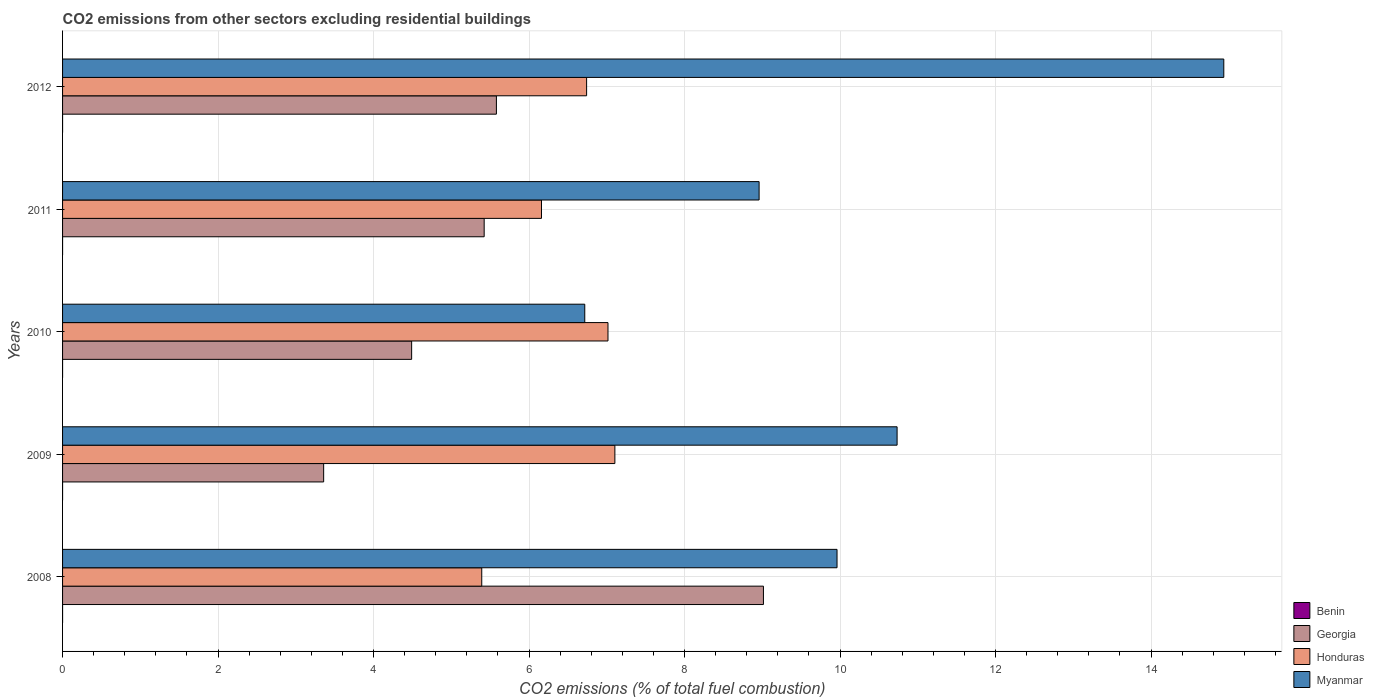Are the number of bars on each tick of the Y-axis equal?
Give a very brief answer. No. How many bars are there on the 1st tick from the top?
Offer a terse response. 4. What is the total CO2 emitted in Honduras in 2008?
Provide a short and direct response. 5.39. Across all years, what is the maximum total CO2 emitted in Georgia?
Your answer should be compact. 9.01. Across all years, what is the minimum total CO2 emitted in Honduras?
Ensure brevity in your answer.  5.39. In which year was the total CO2 emitted in Myanmar maximum?
Your response must be concise. 2012. What is the total total CO2 emitted in Benin in the graph?
Offer a very short reply. 7.807697859994709e-16. What is the difference between the total CO2 emitted in Honduras in 2009 and that in 2012?
Offer a terse response. 0.36. What is the difference between the total CO2 emitted in Honduras in 2010 and the total CO2 emitted in Benin in 2008?
Keep it short and to the point. 7.02. What is the average total CO2 emitted in Honduras per year?
Provide a succinct answer. 6.48. In the year 2012, what is the difference between the total CO2 emitted in Myanmar and total CO2 emitted in Honduras?
Make the answer very short. 8.2. In how many years, is the total CO2 emitted in Benin greater than 6.4 ?
Keep it short and to the point. 0. What is the ratio of the total CO2 emitted in Georgia in 2010 to that in 2012?
Ensure brevity in your answer.  0.8. Is the total CO2 emitted in Myanmar in 2008 less than that in 2009?
Make the answer very short. Yes. Is the difference between the total CO2 emitted in Myanmar in 2008 and 2009 greater than the difference between the total CO2 emitted in Honduras in 2008 and 2009?
Provide a short and direct response. Yes. What is the difference between the highest and the second highest total CO2 emitted in Myanmar?
Keep it short and to the point. 4.2. What is the difference between the highest and the lowest total CO2 emitted in Georgia?
Offer a very short reply. 5.66. Is it the case that in every year, the sum of the total CO2 emitted in Georgia and total CO2 emitted in Benin is greater than the sum of total CO2 emitted in Honduras and total CO2 emitted in Myanmar?
Your answer should be very brief. No. Is it the case that in every year, the sum of the total CO2 emitted in Honduras and total CO2 emitted in Benin is greater than the total CO2 emitted in Myanmar?
Make the answer very short. No. Are all the bars in the graph horizontal?
Your answer should be very brief. Yes. What is the difference between two consecutive major ticks on the X-axis?
Provide a short and direct response. 2. Are the values on the major ticks of X-axis written in scientific E-notation?
Give a very brief answer. No. Does the graph contain any zero values?
Your answer should be very brief. Yes. How are the legend labels stacked?
Give a very brief answer. Vertical. What is the title of the graph?
Offer a very short reply. CO2 emissions from other sectors excluding residential buildings. What is the label or title of the X-axis?
Provide a short and direct response. CO2 emissions (% of total fuel combustion). What is the label or title of the Y-axis?
Provide a short and direct response. Years. What is the CO2 emissions (% of total fuel combustion) in Benin in 2008?
Make the answer very short. 2.282530889443169e-16. What is the CO2 emissions (% of total fuel combustion) of Georgia in 2008?
Offer a terse response. 9.01. What is the CO2 emissions (% of total fuel combustion) of Honduras in 2008?
Your answer should be compact. 5.39. What is the CO2 emissions (% of total fuel combustion) of Myanmar in 2008?
Your answer should be compact. 9.96. What is the CO2 emissions (% of total fuel combustion) in Georgia in 2009?
Keep it short and to the point. 3.36. What is the CO2 emissions (% of total fuel combustion) in Honduras in 2009?
Ensure brevity in your answer.  7.1. What is the CO2 emissions (% of total fuel combustion) in Myanmar in 2009?
Offer a terse response. 10.73. What is the CO2 emissions (% of total fuel combustion) of Benin in 2010?
Make the answer very short. 1.92747052886312e-16. What is the CO2 emissions (% of total fuel combustion) in Georgia in 2010?
Provide a succinct answer. 4.49. What is the CO2 emissions (% of total fuel combustion) of Honduras in 2010?
Offer a very short reply. 7.02. What is the CO2 emissions (% of total fuel combustion) of Myanmar in 2010?
Ensure brevity in your answer.  6.72. What is the CO2 emissions (% of total fuel combustion) of Benin in 2011?
Keep it short and to the point. 1.84545050635831e-16. What is the CO2 emissions (% of total fuel combustion) of Georgia in 2011?
Keep it short and to the point. 5.42. What is the CO2 emissions (% of total fuel combustion) of Honduras in 2011?
Your answer should be compact. 6.16. What is the CO2 emissions (% of total fuel combustion) in Myanmar in 2011?
Ensure brevity in your answer.  8.96. What is the CO2 emissions (% of total fuel combustion) of Benin in 2012?
Give a very brief answer. 1.75224593533011e-16. What is the CO2 emissions (% of total fuel combustion) in Georgia in 2012?
Your response must be concise. 5.58. What is the CO2 emissions (% of total fuel combustion) of Honduras in 2012?
Keep it short and to the point. 6.74. What is the CO2 emissions (% of total fuel combustion) of Myanmar in 2012?
Offer a terse response. 14.94. Across all years, what is the maximum CO2 emissions (% of total fuel combustion) in Benin?
Make the answer very short. 2.282530889443169e-16. Across all years, what is the maximum CO2 emissions (% of total fuel combustion) of Georgia?
Provide a succinct answer. 9.01. Across all years, what is the maximum CO2 emissions (% of total fuel combustion) in Honduras?
Keep it short and to the point. 7.1. Across all years, what is the maximum CO2 emissions (% of total fuel combustion) in Myanmar?
Keep it short and to the point. 14.94. Across all years, what is the minimum CO2 emissions (% of total fuel combustion) of Georgia?
Make the answer very short. 3.36. Across all years, what is the minimum CO2 emissions (% of total fuel combustion) of Honduras?
Your response must be concise. 5.39. Across all years, what is the minimum CO2 emissions (% of total fuel combustion) in Myanmar?
Offer a very short reply. 6.72. What is the total CO2 emissions (% of total fuel combustion) of Georgia in the graph?
Make the answer very short. 27.87. What is the total CO2 emissions (% of total fuel combustion) in Honduras in the graph?
Your answer should be compact. 32.41. What is the total CO2 emissions (% of total fuel combustion) in Myanmar in the graph?
Offer a terse response. 51.31. What is the difference between the CO2 emissions (% of total fuel combustion) in Georgia in 2008 and that in 2009?
Your answer should be compact. 5.66. What is the difference between the CO2 emissions (% of total fuel combustion) in Honduras in 2008 and that in 2009?
Provide a short and direct response. -1.71. What is the difference between the CO2 emissions (% of total fuel combustion) of Myanmar in 2008 and that in 2009?
Provide a succinct answer. -0.77. What is the difference between the CO2 emissions (% of total fuel combustion) of Benin in 2008 and that in 2010?
Ensure brevity in your answer.  0. What is the difference between the CO2 emissions (% of total fuel combustion) of Georgia in 2008 and that in 2010?
Your response must be concise. 4.52. What is the difference between the CO2 emissions (% of total fuel combustion) of Honduras in 2008 and that in 2010?
Your answer should be compact. -1.62. What is the difference between the CO2 emissions (% of total fuel combustion) of Myanmar in 2008 and that in 2010?
Make the answer very short. 3.24. What is the difference between the CO2 emissions (% of total fuel combustion) in Benin in 2008 and that in 2011?
Provide a succinct answer. 0. What is the difference between the CO2 emissions (% of total fuel combustion) of Georgia in 2008 and that in 2011?
Provide a short and direct response. 3.59. What is the difference between the CO2 emissions (% of total fuel combustion) of Honduras in 2008 and that in 2011?
Provide a short and direct response. -0.77. What is the difference between the CO2 emissions (% of total fuel combustion) of Myanmar in 2008 and that in 2011?
Offer a terse response. 1. What is the difference between the CO2 emissions (% of total fuel combustion) of Benin in 2008 and that in 2012?
Provide a short and direct response. 0. What is the difference between the CO2 emissions (% of total fuel combustion) of Georgia in 2008 and that in 2012?
Give a very brief answer. 3.43. What is the difference between the CO2 emissions (% of total fuel combustion) in Honduras in 2008 and that in 2012?
Provide a short and direct response. -1.35. What is the difference between the CO2 emissions (% of total fuel combustion) in Myanmar in 2008 and that in 2012?
Your response must be concise. -4.97. What is the difference between the CO2 emissions (% of total fuel combustion) in Georgia in 2009 and that in 2010?
Offer a very short reply. -1.13. What is the difference between the CO2 emissions (% of total fuel combustion) in Honduras in 2009 and that in 2010?
Your response must be concise. 0.09. What is the difference between the CO2 emissions (% of total fuel combustion) of Myanmar in 2009 and that in 2010?
Keep it short and to the point. 4.02. What is the difference between the CO2 emissions (% of total fuel combustion) of Georgia in 2009 and that in 2011?
Provide a short and direct response. -2.06. What is the difference between the CO2 emissions (% of total fuel combustion) of Honduras in 2009 and that in 2011?
Your answer should be compact. 0.94. What is the difference between the CO2 emissions (% of total fuel combustion) in Myanmar in 2009 and that in 2011?
Make the answer very short. 1.77. What is the difference between the CO2 emissions (% of total fuel combustion) in Georgia in 2009 and that in 2012?
Offer a terse response. -2.22. What is the difference between the CO2 emissions (% of total fuel combustion) of Honduras in 2009 and that in 2012?
Your answer should be compact. 0.36. What is the difference between the CO2 emissions (% of total fuel combustion) of Myanmar in 2009 and that in 2012?
Your response must be concise. -4.2. What is the difference between the CO2 emissions (% of total fuel combustion) of Benin in 2010 and that in 2011?
Your answer should be compact. 0. What is the difference between the CO2 emissions (% of total fuel combustion) in Georgia in 2010 and that in 2011?
Provide a succinct answer. -0.93. What is the difference between the CO2 emissions (% of total fuel combustion) in Honduras in 2010 and that in 2011?
Offer a terse response. 0.86. What is the difference between the CO2 emissions (% of total fuel combustion) of Myanmar in 2010 and that in 2011?
Make the answer very short. -2.24. What is the difference between the CO2 emissions (% of total fuel combustion) in Benin in 2010 and that in 2012?
Your answer should be compact. 0. What is the difference between the CO2 emissions (% of total fuel combustion) of Georgia in 2010 and that in 2012?
Ensure brevity in your answer.  -1.09. What is the difference between the CO2 emissions (% of total fuel combustion) of Honduras in 2010 and that in 2012?
Your answer should be compact. 0.27. What is the difference between the CO2 emissions (% of total fuel combustion) of Myanmar in 2010 and that in 2012?
Make the answer very short. -8.22. What is the difference between the CO2 emissions (% of total fuel combustion) of Benin in 2011 and that in 2012?
Your answer should be compact. 0. What is the difference between the CO2 emissions (% of total fuel combustion) in Georgia in 2011 and that in 2012?
Provide a short and direct response. -0.16. What is the difference between the CO2 emissions (% of total fuel combustion) in Honduras in 2011 and that in 2012?
Keep it short and to the point. -0.58. What is the difference between the CO2 emissions (% of total fuel combustion) of Myanmar in 2011 and that in 2012?
Your answer should be very brief. -5.98. What is the difference between the CO2 emissions (% of total fuel combustion) of Benin in 2008 and the CO2 emissions (% of total fuel combustion) of Georgia in 2009?
Ensure brevity in your answer.  -3.36. What is the difference between the CO2 emissions (% of total fuel combustion) of Benin in 2008 and the CO2 emissions (% of total fuel combustion) of Honduras in 2009?
Ensure brevity in your answer.  -7.1. What is the difference between the CO2 emissions (% of total fuel combustion) of Benin in 2008 and the CO2 emissions (% of total fuel combustion) of Myanmar in 2009?
Offer a very short reply. -10.73. What is the difference between the CO2 emissions (% of total fuel combustion) of Georgia in 2008 and the CO2 emissions (% of total fuel combustion) of Honduras in 2009?
Offer a very short reply. 1.91. What is the difference between the CO2 emissions (% of total fuel combustion) of Georgia in 2008 and the CO2 emissions (% of total fuel combustion) of Myanmar in 2009?
Make the answer very short. -1.72. What is the difference between the CO2 emissions (% of total fuel combustion) in Honduras in 2008 and the CO2 emissions (% of total fuel combustion) in Myanmar in 2009?
Your answer should be compact. -5.34. What is the difference between the CO2 emissions (% of total fuel combustion) of Benin in 2008 and the CO2 emissions (% of total fuel combustion) of Georgia in 2010?
Provide a short and direct response. -4.49. What is the difference between the CO2 emissions (% of total fuel combustion) of Benin in 2008 and the CO2 emissions (% of total fuel combustion) of Honduras in 2010?
Offer a terse response. -7.02. What is the difference between the CO2 emissions (% of total fuel combustion) of Benin in 2008 and the CO2 emissions (% of total fuel combustion) of Myanmar in 2010?
Your answer should be very brief. -6.72. What is the difference between the CO2 emissions (% of total fuel combustion) of Georgia in 2008 and the CO2 emissions (% of total fuel combustion) of Honduras in 2010?
Offer a terse response. 2. What is the difference between the CO2 emissions (% of total fuel combustion) of Georgia in 2008 and the CO2 emissions (% of total fuel combustion) of Myanmar in 2010?
Ensure brevity in your answer.  2.3. What is the difference between the CO2 emissions (% of total fuel combustion) in Honduras in 2008 and the CO2 emissions (% of total fuel combustion) in Myanmar in 2010?
Your answer should be very brief. -1.32. What is the difference between the CO2 emissions (% of total fuel combustion) in Benin in 2008 and the CO2 emissions (% of total fuel combustion) in Georgia in 2011?
Provide a succinct answer. -5.42. What is the difference between the CO2 emissions (% of total fuel combustion) of Benin in 2008 and the CO2 emissions (% of total fuel combustion) of Honduras in 2011?
Offer a very short reply. -6.16. What is the difference between the CO2 emissions (% of total fuel combustion) in Benin in 2008 and the CO2 emissions (% of total fuel combustion) in Myanmar in 2011?
Give a very brief answer. -8.96. What is the difference between the CO2 emissions (% of total fuel combustion) of Georgia in 2008 and the CO2 emissions (% of total fuel combustion) of Honduras in 2011?
Provide a short and direct response. 2.85. What is the difference between the CO2 emissions (% of total fuel combustion) of Georgia in 2008 and the CO2 emissions (% of total fuel combustion) of Myanmar in 2011?
Keep it short and to the point. 0.06. What is the difference between the CO2 emissions (% of total fuel combustion) in Honduras in 2008 and the CO2 emissions (% of total fuel combustion) in Myanmar in 2011?
Keep it short and to the point. -3.57. What is the difference between the CO2 emissions (% of total fuel combustion) of Benin in 2008 and the CO2 emissions (% of total fuel combustion) of Georgia in 2012?
Keep it short and to the point. -5.58. What is the difference between the CO2 emissions (% of total fuel combustion) of Benin in 2008 and the CO2 emissions (% of total fuel combustion) of Honduras in 2012?
Your answer should be compact. -6.74. What is the difference between the CO2 emissions (% of total fuel combustion) in Benin in 2008 and the CO2 emissions (% of total fuel combustion) in Myanmar in 2012?
Keep it short and to the point. -14.94. What is the difference between the CO2 emissions (% of total fuel combustion) of Georgia in 2008 and the CO2 emissions (% of total fuel combustion) of Honduras in 2012?
Offer a terse response. 2.27. What is the difference between the CO2 emissions (% of total fuel combustion) in Georgia in 2008 and the CO2 emissions (% of total fuel combustion) in Myanmar in 2012?
Your response must be concise. -5.92. What is the difference between the CO2 emissions (% of total fuel combustion) in Honduras in 2008 and the CO2 emissions (% of total fuel combustion) in Myanmar in 2012?
Provide a short and direct response. -9.54. What is the difference between the CO2 emissions (% of total fuel combustion) of Georgia in 2009 and the CO2 emissions (% of total fuel combustion) of Honduras in 2010?
Give a very brief answer. -3.66. What is the difference between the CO2 emissions (% of total fuel combustion) in Georgia in 2009 and the CO2 emissions (% of total fuel combustion) in Myanmar in 2010?
Ensure brevity in your answer.  -3.36. What is the difference between the CO2 emissions (% of total fuel combustion) in Honduras in 2009 and the CO2 emissions (% of total fuel combustion) in Myanmar in 2010?
Your response must be concise. 0.39. What is the difference between the CO2 emissions (% of total fuel combustion) of Georgia in 2009 and the CO2 emissions (% of total fuel combustion) of Honduras in 2011?
Keep it short and to the point. -2.8. What is the difference between the CO2 emissions (% of total fuel combustion) of Georgia in 2009 and the CO2 emissions (% of total fuel combustion) of Myanmar in 2011?
Make the answer very short. -5.6. What is the difference between the CO2 emissions (% of total fuel combustion) of Honduras in 2009 and the CO2 emissions (% of total fuel combustion) of Myanmar in 2011?
Keep it short and to the point. -1.85. What is the difference between the CO2 emissions (% of total fuel combustion) in Georgia in 2009 and the CO2 emissions (% of total fuel combustion) in Honduras in 2012?
Make the answer very short. -3.38. What is the difference between the CO2 emissions (% of total fuel combustion) of Georgia in 2009 and the CO2 emissions (% of total fuel combustion) of Myanmar in 2012?
Offer a terse response. -11.58. What is the difference between the CO2 emissions (% of total fuel combustion) of Honduras in 2009 and the CO2 emissions (% of total fuel combustion) of Myanmar in 2012?
Provide a short and direct response. -7.83. What is the difference between the CO2 emissions (% of total fuel combustion) of Benin in 2010 and the CO2 emissions (% of total fuel combustion) of Georgia in 2011?
Offer a very short reply. -5.42. What is the difference between the CO2 emissions (% of total fuel combustion) of Benin in 2010 and the CO2 emissions (% of total fuel combustion) of Honduras in 2011?
Offer a terse response. -6.16. What is the difference between the CO2 emissions (% of total fuel combustion) of Benin in 2010 and the CO2 emissions (% of total fuel combustion) of Myanmar in 2011?
Give a very brief answer. -8.96. What is the difference between the CO2 emissions (% of total fuel combustion) of Georgia in 2010 and the CO2 emissions (% of total fuel combustion) of Honduras in 2011?
Ensure brevity in your answer.  -1.67. What is the difference between the CO2 emissions (% of total fuel combustion) in Georgia in 2010 and the CO2 emissions (% of total fuel combustion) in Myanmar in 2011?
Provide a short and direct response. -4.47. What is the difference between the CO2 emissions (% of total fuel combustion) in Honduras in 2010 and the CO2 emissions (% of total fuel combustion) in Myanmar in 2011?
Make the answer very short. -1.94. What is the difference between the CO2 emissions (% of total fuel combustion) in Benin in 2010 and the CO2 emissions (% of total fuel combustion) in Georgia in 2012?
Make the answer very short. -5.58. What is the difference between the CO2 emissions (% of total fuel combustion) in Benin in 2010 and the CO2 emissions (% of total fuel combustion) in Honduras in 2012?
Your answer should be compact. -6.74. What is the difference between the CO2 emissions (% of total fuel combustion) in Benin in 2010 and the CO2 emissions (% of total fuel combustion) in Myanmar in 2012?
Make the answer very short. -14.94. What is the difference between the CO2 emissions (% of total fuel combustion) in Georgia in 2010 and the CO2 emissions (% of total fuel combustion) in Honduras in 2012?
Ensure brevity in your answer.  -2.25. What is the difference between the CO2 emissions (% of total fuel combustion) in Georgia in 2010 and the CO2 emissions (% of total fuel combustion) in Myanmar in 2012?
Ensure brevity in your answer.  -10.45. What is the difference between the CO2 emissions (% of total fuel combustion) in Honduras in 2010 and the CO2 emissions (% of total fuel combustion) in Myanmar in 2012?
Provide a succinct answer. -7.92. What is the difference between the CO2 emissions (% of total fuel combustion) in Benin in 2011 and the CO2 emissions (% of total fuel combustion) in Georgia in 2012?
Offer a very short reply. -5.58. What is the difference between the CO2 emissions (% of total fuel combustion) of Benin in 2011 and the CO2 emissions (% of total fuel combustion) of Honduras in 2012?
Provide a short and direct response. -6.74. What is the difference between the CO2 emissions (% of total fuel combustion) in Benin in 2011 and the CO2 emissions (% of total fuel combustion) in Myanmar in 2012?
Your answer should be very brief. -14.94. What is the difference between the CO2 emissions (% of total fuel combustion) of Georgia in 2011 and the CO2 emissions (% of total fuel combustion) of Honduras in 2012?
Offer a very short reply. -1.32. What is the difference between the CO2 emissions (% of total fuel combustion) in Georgia in 2011 and the CO2 emissions (% of total fuel combustion) in Myanmar in 2012?
Offer a terse response. -9.51. What is the difference between the CO2 emissions (% of total fuel combustion) in Honduras in 2011 and the CO2 emissions (% of total fuel combustion) in Myanmar in 2012?
Ensure brevity in your answer.  -8.78. What is the average CO2 emissions (% of total fuel combustion) of Georgia per year?
Ensure brevity in your answer.  5.57. What is the average CO2 emissions (% of total fuel combustion) of Honduras per year?
Offer a very short reply. 6.48. What is the average CO2 emissions (% of total fuel combustion) of Myanmar per year?
Your response must be concise. 10.26. In the year 2008, what is the difference between the CO2 emissions (% of total fuel combustion) in Benin and CO2 emissions (% of total fuel combustion) in Georgia?
Give a very brief answer. -9.01. In the year 2008, what is the difference between the CO2 emissions (% of total fuel combustion) of Benin and CO2 emissions (% of total fuel combustion) of Honduras?
Your response must be concise. -5.39. In the year 2008, what is the difference between the CO2 emissions (% of total fuel combustion) in Benin and CO2 emissions (% of total fuel combustion) in Myanmar?
Your response must be concise. -9.96. In the year 2008, what is the difference between the CO2 emissions (% of total fuel combustion) in Georgia and CO2 emissions (% of total fuel combustion) in Honduras?
Your answer should be very brief. 3.62. In the year 2008, what is the difference between the CO2 emissions (% of total fuel combustion) in Georgia and CO2 emissions (% of total fuel combustion) in Myanmar?
Your response must be concise. -0.95. In the year 2008, what is the difference between the CO2 emissions (% of total fuel combustion) of Honduras and CO2 emissions (% of total fuel combustion) of Myanmar?
Ensure brevity in your answer.  -4.57. In the year 2009, what is the difference between the CO2 emissions (% of total fuel combustion) in Georgia and CO2 emissions (% of total fuel combustion) in Honduras?
Give a very brief answer. -3.75. In the year 2009, what is the difference between the CO2 emissions (% of total fuel combustion) of Georgia and CO2 emissions (% of total fuel combustion) of Myanmar?
Ensure brevity in your answer.  -7.38. In the year 2009, what is the difference between the CO2 emissions (% of total fuel combustion) of Honduras and CO2 emissions (% of total fuel combustion) of Myanmar?
Offer a very short reply. -3.63. In the year 2010, what is the difference between the CO2 emissions (% of total fuel combustion) of Benin and CO2 emissions (% of total fuel combustion) of Georgia?
Ensure brevity in your answer.  -4.49. In the year 2010, what is the difference between the CO2 emissions (% of total fuel combustion) of Benin and CO2 emissions (% of total fuel combustion) of Honduras?
Provide a succinct answer. -7.02. In the year 2010, what is the difference between the CO2 emissions (% of total fuel combustion) in Benin and CO2 emissions (% of total fuel combustion) in Myanmar?
Make the answer very short. -6.72. In the year 2010, what is the difference between the CO2 emissions (% of total fuel combustion) of Georgia and CO2 emissions (% of total fuel combustion) of Honduras?
Offer a very short reply. -2.53. In the year 2010, what is the difference between the CO2 emissions (% of total fuel combustion) in Georgia and CO2 emissions (% of total fuel combustion) in Myanmar?
Offer a terse response. -2.23. In the year 2010, what is the difference between the CO2 emissions (% of total fuel combustion) in Honduras and CO2 emissions (% of total fuel combustion) in Myanmar?
Your response must be concise. 0.3. In the year 2011, what is the difference between the CO2 emissions (% of total fuel combustion) of Benin and CO2 emissions (% of total fuel combustion) of Georgia?
Give a very brief answer. -5.42. In the year 2011, what is the difference between the CO2 emissions (% of total fuel combustion) in Benin and CO2 emissions (% of total fuel combustion) in Honduras?
Keep it short and to the point. -6.16. In the year 2011, what is the difference between the CO2 emissions (% of total fuel combustion) of Benin and CO2 emissions (% of total fuel combustion) of Myanmar?
Offer a terse response. -8.96. In the year 2011, what is the difference between the CO2 emissions (% of total fuel combustion) in Georgia and CO2 emissions (% of total fuel combustion) in Honduras?
Offer a terse response. -0.74. In the year 2011, what is the difference between the CO2 emissions (% of total fuel combustion) in Georgia and CO2 emissions (% of total fuel combustion) in Myanmar?
Your response must be concise. -3.54. In the year 2011, what is the difference between the CO2 emissions (% of total fuel combustion) in Honduras and CO2 emissions (% of total fuel combustion) in Myanmar?
Offer a terse response. -2.8. In the year 2012, what is the difference between the CO2 emissions (% of total fuel combustion) of Benin and CO2 emissions (% of total fuel combustion) of Georgia?
Give a very brief answer. -5.58. In the year 2012, what is the difference between the CO2 emissions (% of total fuel combustion) in Benin and CO2 emissions (% of total fuel combustion) in Honduras?
Your response must be concise. -6.74. In the year 2012, what is the difference between the CO2 emissions (% of total fuel combustion) in Benin and CO2 emissions (% of total fuel combustion) in Myanmar?
Provide a short and direct response. -14.94. In the year 2012, what is the difference between the CO2 emissions (% of total fuel combustion) of Georgia and CO2 emissions (% of total fuel combustion) of Honduras?
Give a very brief answer. -1.16. In the year 2012, what is the difference between the CO2 emissions (% of total fuel combustion) in Georgia and CO2 emissions (% of total fuel combustion) in Myanmar?
Your answer should be compact. -9.36. In the year 2012, what is the difference between the CO2 emissions (% of total fuel combustion) of Honduras and CO2 emissions (% of total fuel combustion) of Myanmar?
Make the answer very short. -8.2. What is the ratio of the CO2 emissions (% of total fuel combustion) in Georgia in 2008 to that in 2009?
Your response must be concise. 2.68. What is the ratio of the CO2 emissions (% of total fuel combustion) of Honduras in 2008 to that in 2009?
Provide a succinct answer. 0.76. What is the ratio of the CO2 emissions (% of total fuel combustion) of Myanmar in 2008 to that in 2009?
Keep it short and to the point. 0.93. What is the ratio of the CO2 emissions (% of total fuel combustion) in Benin in 2008 to that in 2010?
Your answer should be compact. 1.18. What is the ratio of the CO2 emissions (% of total fuel combustion) in Georgia in 2008 to that in 2010?
Your answer should be compact. 2.01. What is the ratio of the CO2 emissions (% of total fuel combustion) of Honduras in 2008 to that in 2010?
Provide a short and direct response. 0.77. What is the ratio of the CO2 emissions (% of total fuel combustion) in Myanmar in 2008 to that in 2010?
Give a very brief answer. 1.48. What is the ratio of the CO2 emissions (% of total fuel combustion) of Benin in 2008 to that in 2011?
Ensure brevity in your answer.  1.24. What is the ratio of the CO2 emissions (% of total fuel combustion) of Georgia in 2008 to that in 2011?
Your answer should be very brief. 1.66. What is the ratio of the CO2 emissions (% of total fuel combustion) in Honduras in 2008 to that in 2011?
Your answer should be very brief. 0.88. What is the ratio of the CO2 emissions (% of total fuel combustion) in Myanmar in 2008 to that in 2011?
Your response must be concise. 1.11. What is the ratio of the CO2 emissions (% of total fuel combustion) of Benin in 2008 to that in 2012?
Your answer should be very brief. 1.3. What is the ratio of the CO2 emissions (% of total fuel combustion) of Georgia in 2008 to that in 2012?
Offer a terse response. 1.62. What is the ratio of the CO2 emissions (% of total fuel combustion) in Honduras in 2008 to that in 2012?
Give a very brief answer. 0.8. What is the ratio of the CO2 emissions (% of total fuel combustion) of Myanmar in 2008 to that in 2012?
Provide a short and direct response. 0.67. What is the ratio of the CO2 emissions (% of total fuel combustion) in Georgia in 2009 to that in 2010?
Your answer should be compact. 0.75. What is the ratio of the CO2 emissions (% of total fuel combustion) of Honduras in 2009 to that in 2010?
Offer a terse response. 1.01. What is the ratio of the CO2 emissions (% of total fuel combustion) of Myanmar in 2009 to that in 2010?
Offer a terse response. 1.6. What is the ratio of the CO2 emissions (% of total fuel combustion) of Georgia in 2009 to that in 2011?
Provide a succinct answer. 0.62. What is the ratio of the CO2 emissions (% of total fuel combustion) in Honduras in 2009 to that in 2011?
Make the answer very short. 1.15. What is the ratio of the CO2 emissions (% of total fuel combustion) in Myanmar in 2009 to that in 2011?
Your response must be concise. 1.2. What is the ratio of the CO2 emissions (% of total fuel combustion) in Georgia in 2009 to that in 2012?
Make the answer very short. 0.6. What is the ratio of the CO2 emissions (% of total fuel combustion) in Honduras in 2009 to that in 2012?
Your answer should be very brief. 1.05. What is the ratio of the CO2 emissions (% of total fuel combustion) in Myanmar in 2009 to that in 2012?
Your answer should be very brief. 0.72. What is the ratio of the CO2 emissions (% of total fuel combustion) in Benin in 2010 to that in 2011?
Give a very brief answer. 1.04. What is the ratio of the CO2 emissions (% of total fuel combustion) of Georgia in 2010 to that in 2011?
Keep it short and to the point. 0.83. What is the ratio of the CO2 emissions (% of total fuel combustion) of Honduras in 2010 to that in 2011?
Keep it short and to the point. 1.14. What is the ratio of the CO2 emissions (% of total fuel combustion) of Myanmar in 2010 to that in 2011?
Your answer should be very brief. 0.75. What is the ratio of the CO2 emissions (% of total fuel combustion) in Benin in 2010 to that in 2012?
Provide a short and direct response. 1.1. What is the ratio of the CO2 emissions (% of total fuel combustion) of Georgia in 2010 to that in 2012?
Your answer should be very brief. 0.8. What is the ratio of the CO2 emissions (% of total fuel combustion) in Honduras in 2010 to that in 2012?
Your answer should be very brief. 1.04. What is the ratio of the CO2 emissions (% of total fuel combustion) of Myanmar in 2010 to that in 2012?
Make the answer very short. 0.45. What is the ratio of the CO2 emissions (% of total fuel combustion) in Benin in 2011 to that in 2012?
Offer a terse response. 1.05. What is the ratio of the CO2 emissions (% of total fuel combustion) of Georgia in 2011 to that in 2012?
Make the answer very short. 0.97. What is the ratio of the CO2 emissions (% of total fuel combustion) of Honduras in 2011 to that in 2012?
Your answer should be compact. 0.91. What is the ratio of the CO2 emissions (% of total fuel combustion) in Myanmar in 2011 to that in 2012?
Ensure brevity in your answer.  0.6. What is the difference between the highest and the second highest CO2 emissions (% of total fuel combustion) of Benin?
Make the answer very short. 0. What is the difference between the highest and the second highest CO2 emissions (% of total fuel combustion) of Georgia?
Keep it short and to the point. 3.43. What is the difference between the highest and the second highest CO2 emissions (% of total fuel combustion) in Honduras?
Your answer should be compact. 0.09. What is the difference between the highest and the second highest CO2 emissions (% of total fuel combustion) in Myanmar?
Provide a short and direct response. 4.2. What is the difference between the highest and the lowest CO2 emissions (% of total fuel combustion) of Georgia?
Offer a terse response. 5.66. What is the difference between the highest and the lowest CO2 emissions (% of total fuel combustion) of Honduras?
Your answer should be compact. 1.71. What is the difference between the highest and the lowest CO2 emissions (% of total fuel combustion) in Myanmar?
Make the answer very short. 8.22. 